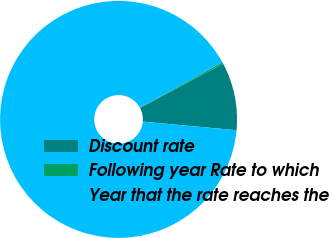Convert chart to OTSL. <chart><loc_0><loc_0><loc_500><loc_500><pie_chart><fcel>Discount rate<fcel>Following year Rate to which<fcel>Year that the rate reaches the<nl><fcel>9.25%<fcel>0.22%<fcel>90.52%<nl></chart> 